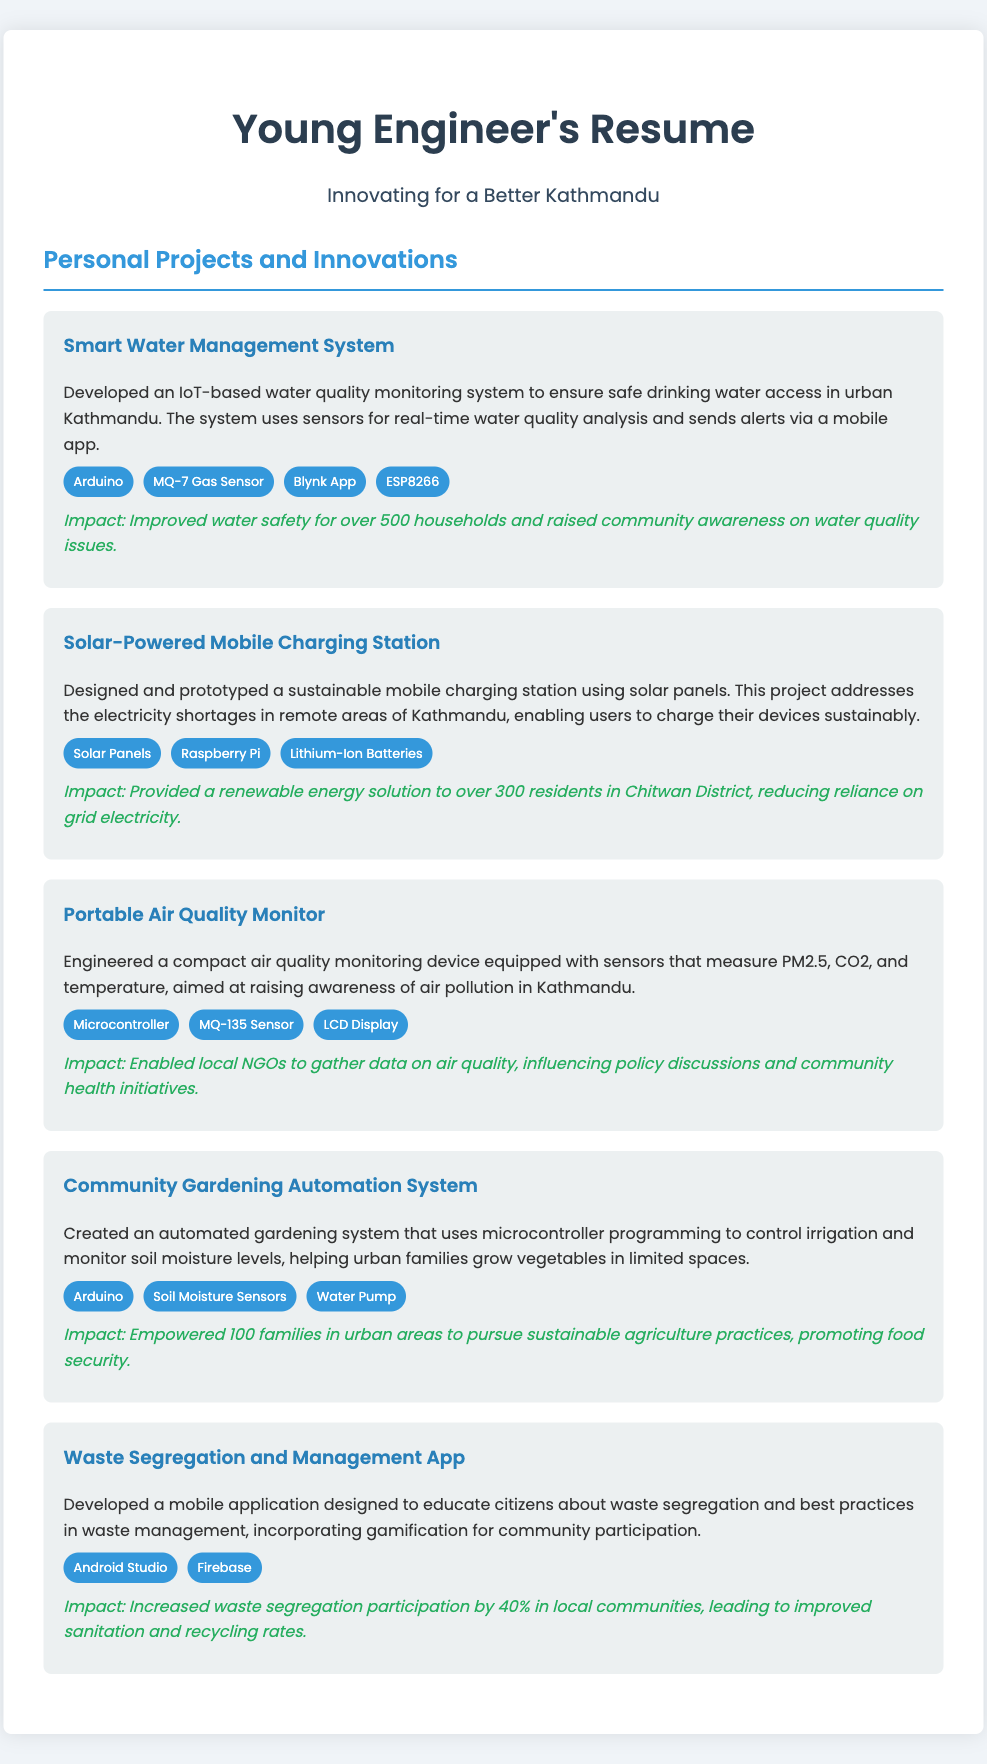What is the title of the first project? The title of the first project is mentioned under the "Personal Projects and Innovations" section as the "Smart Water Management System."
Answer: Smart Water Management System How many households benefited from the Smart Water Management System? The document states that the Smart Water Management System improved water safety for over 500 households.
Answer: 500 households What technology is used in the Solar-Powered Mobile Charging Station? The document lists Solar Panels, Raspberry Pi, and Lithium-Ion Batteries as the technologies used in the Solar-Powered Mobile Charging Station.
Answer: Solar Panels, Raspberry Pi, Lithium-Ion Batteries What was the impact of the Portable Air Quality Monitor? The Portable Air Quality Monitor enabled local NGOs to gather data on air quality, influencing policy discussions and community health initiatives.
Answer: Enabled local NGOs to gather data How many families were empowered by the Community Gardening Automation System? The impact statement for the Community Gardening Automation System mentions that 100 families in urban areas were empowered.
Answer: 100 families What is the main purpose of the Waste Segregation and Management App? The main purpose of the app, as stated in the document, is to educate citizens about waste segregation and best practices in waste management.
Answer: Educate citizens about waste segregation Which sensors are used in the Community Gardening Automation System? The document specifies that Soil Moisture Sensors are used in the Community Gardening Automation System along with Arduino and Water Pump.
Answer: Soil Moisture Sensors What programming platform was used for the Waste Segregation and Management App? The app was developed using Android Studio, as mentioned in the technologies section.
Answer: Android Studio 